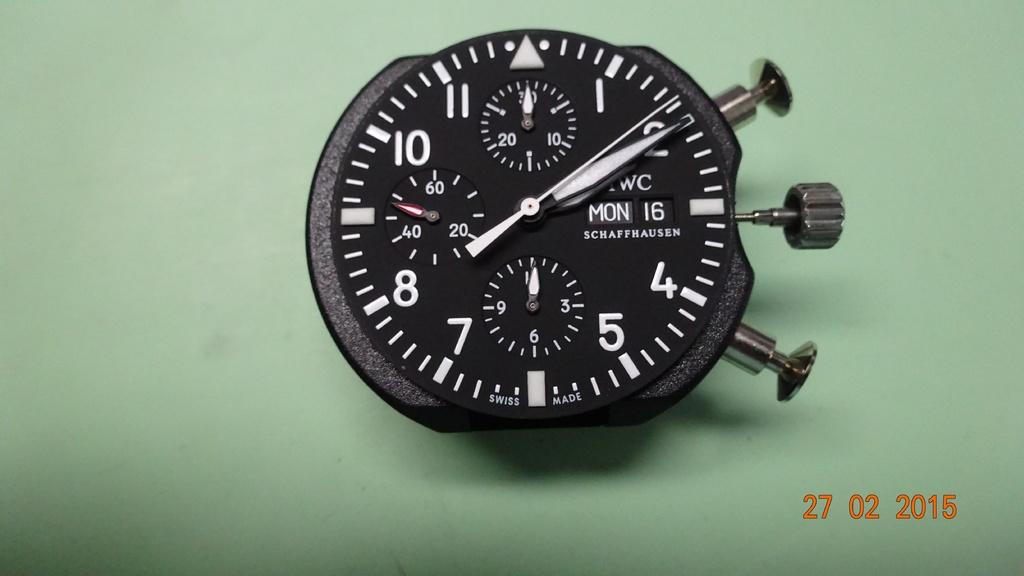<image>
Provide a brief description of the given image. Face of a wristwatch which says the date is Monday 16th. 